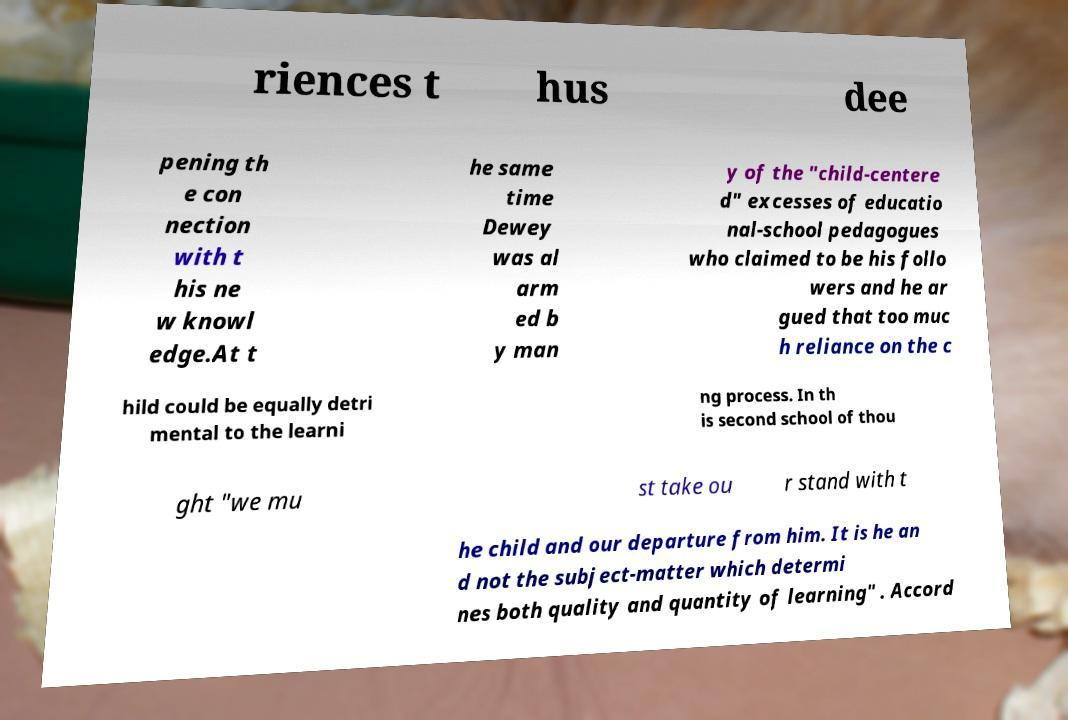I need the written content from this picture converted into text. Can you do that? riences t hus dee pening th e con nection with t his ne w knowl edge.At t he same time Dewey was al arm ed b y man y of the "child-centere d" excesses of educatio nal-school pedagogues who claimed to be his follo wers and he ar gued that too muc h reliance on the c hild could be equally detri mental to the learni ng process. In th is second school of thou ght "we mu st take ou r stand with t he child and our departure from him. It is he an d not the subject-matter which determi nes both quality and quantity of learning" . Accord 